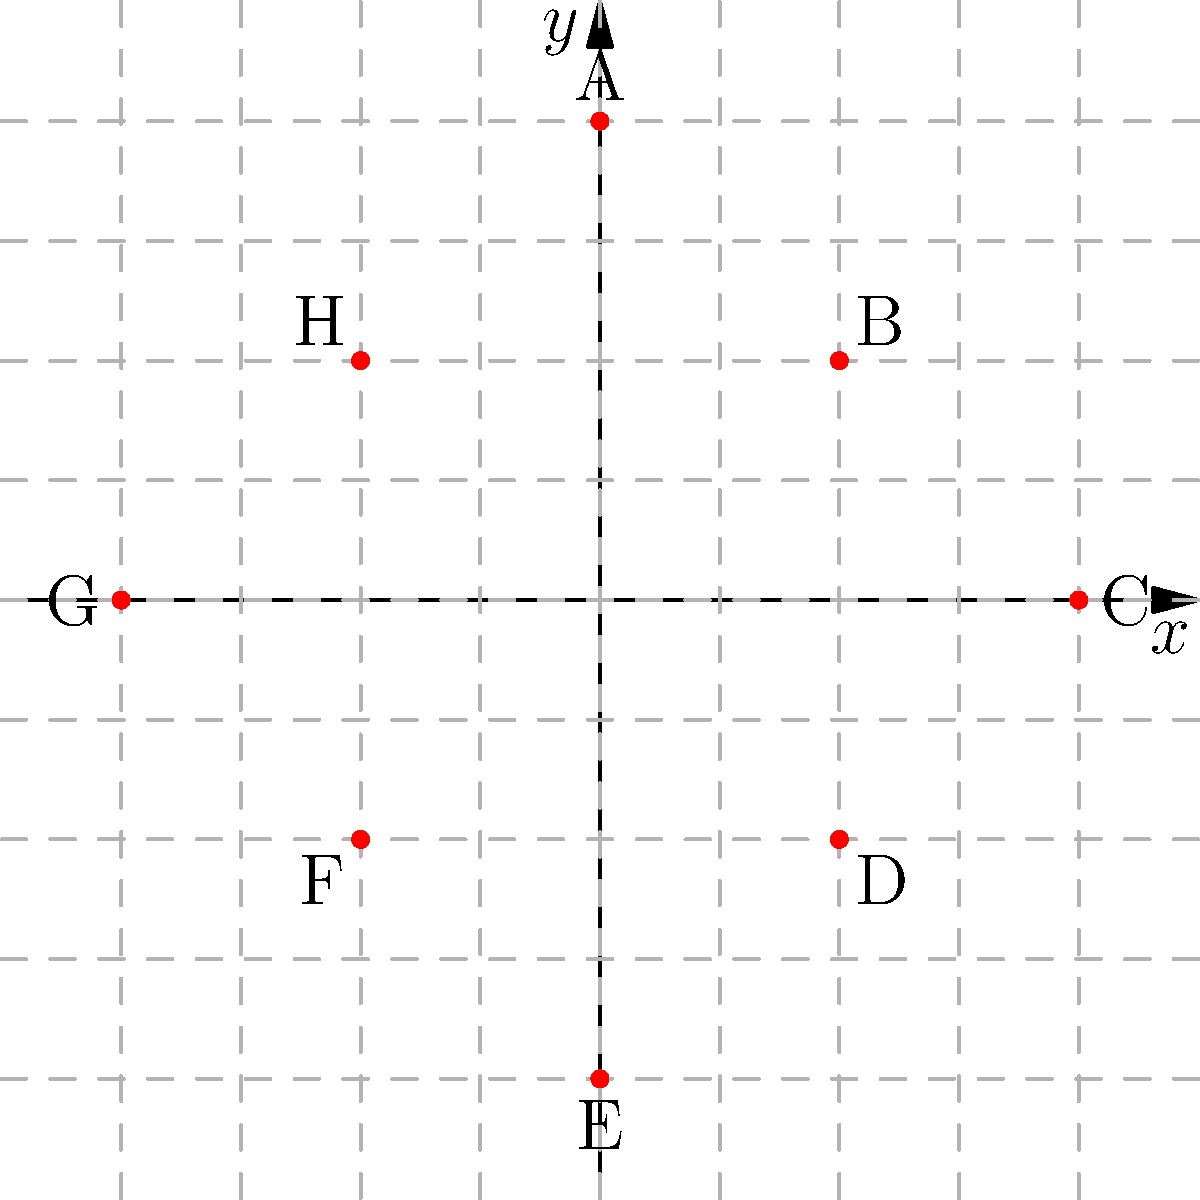You've been tasked with creating a "pun-tastic" coordinate plane masterpiece! Plot the following points and connect them in alphabetical order to reveal a shape that's sure to make you smile:

A(0,4), B(2,2), C(4,0), D(2,-2), E(0,-4), F(-2,-2), G(-4,0), H(-2,2)

What witty shape have you created? (Hint: It's not a square deal, but it's pretty hip!) Let's follow these steps to solve the puzzle:

1. Plot all the given points on the coordinate plane:
   A(0,4), B(2,2), C(4,0), D(2,-2), E(0,-4), F(-2,-2), G(-4,0), H(-2,2)

2. Connect the points in alphabetical order:
   A → B → C → D → E → F → G → H → A (to close the shape)

3. Analyze the resulting shape:
   - The shape has 8 sides of equal length.
   - The angles between adjacent sides are equal.
   - It resembles a diamond or rhombus, but rotated 45 degrees.

4. Identify the shape:
   The shape formed is an octagon, which is a polygon with 8 sides and 8 angles.

5. Connect the shape to the pun hint:
   The hint mentions "not a square deal, but it's pretty hip." This is a play on words:
   - "Square deal" refers to the shape not being a square.
   - "Hip" is a pun because an octagon is often associated with the shape of a stop sign, which could be considered "hip" or cool.

Therefore, the witty shape created is an octagon, which fits the pun-loving persona of a high schooler by creating a shape that's "hip to be square" (another pun, referencing a popular song).
Answer: Octagon 